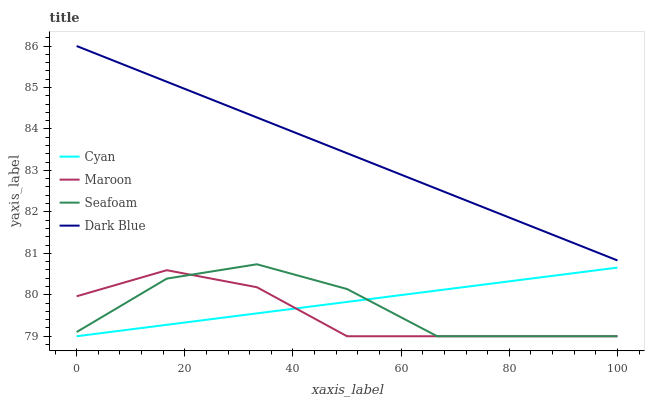Does Maroon have the minimum area under the curve?
Answer yes or no. Yes. Does Dark Blue have the maximum area under the curve?
Answer yes or no. Yes. Does Seafoam have the minimum area under the curve?
Answer yes or no. No. Does Seafoam have the maximum area under the curve?
Answer yes or no. No. Is Dark Blue the smoothest?
Answer yes or no. Yes. Is Seafoam the roughest?
Answer yes or no. Yes. Is Maroon the smoothest?
Answer yes or no. No. Is Maroon the roughest?
Answer yes or no. No. Does Cyan have the lowest value?
Answer yes or no. Yes. Does Dark Blue have the lowest value?
Answer yes or no. No. Does Dark Blue have the highest value?
Answer yes or no. Yes. Does Seafoam have the highest value?
Answer yes or no. No. Is Cyan less than Dark Blue?
Answer yes or no. Yes. Is Dark Blue greater than Maroon?
Answer yes or no. Yes. Does Maroon intersect Seafoam?
Answer yes or no. Yes. Is Maroon less than Seafoam?
Answer yes or no. No. Is Maroon greater than Seafoam?
Answer yes or no. No. Does Cyan intersect Dark Blue?
Answer yes or no. No. 